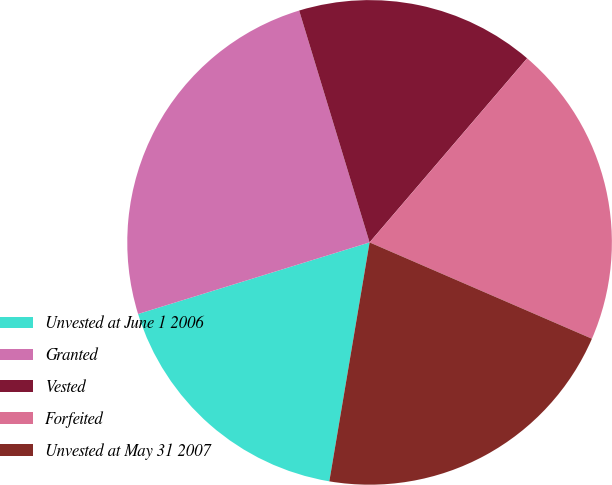Convert chart. <chart><loc_0><loc_0><loc_500><loc_500><pie_chart><fcel>Unvested at June 1 2006<fcel>Granted<fcel>Vested<fcel>Forfeited<fcel>Unvested at May 31 2007<nl><fcel>17.57%<fcel>25.08%<fcel>15.96%<fcel>20.24%<fcel>21.15%<nl></chart> 